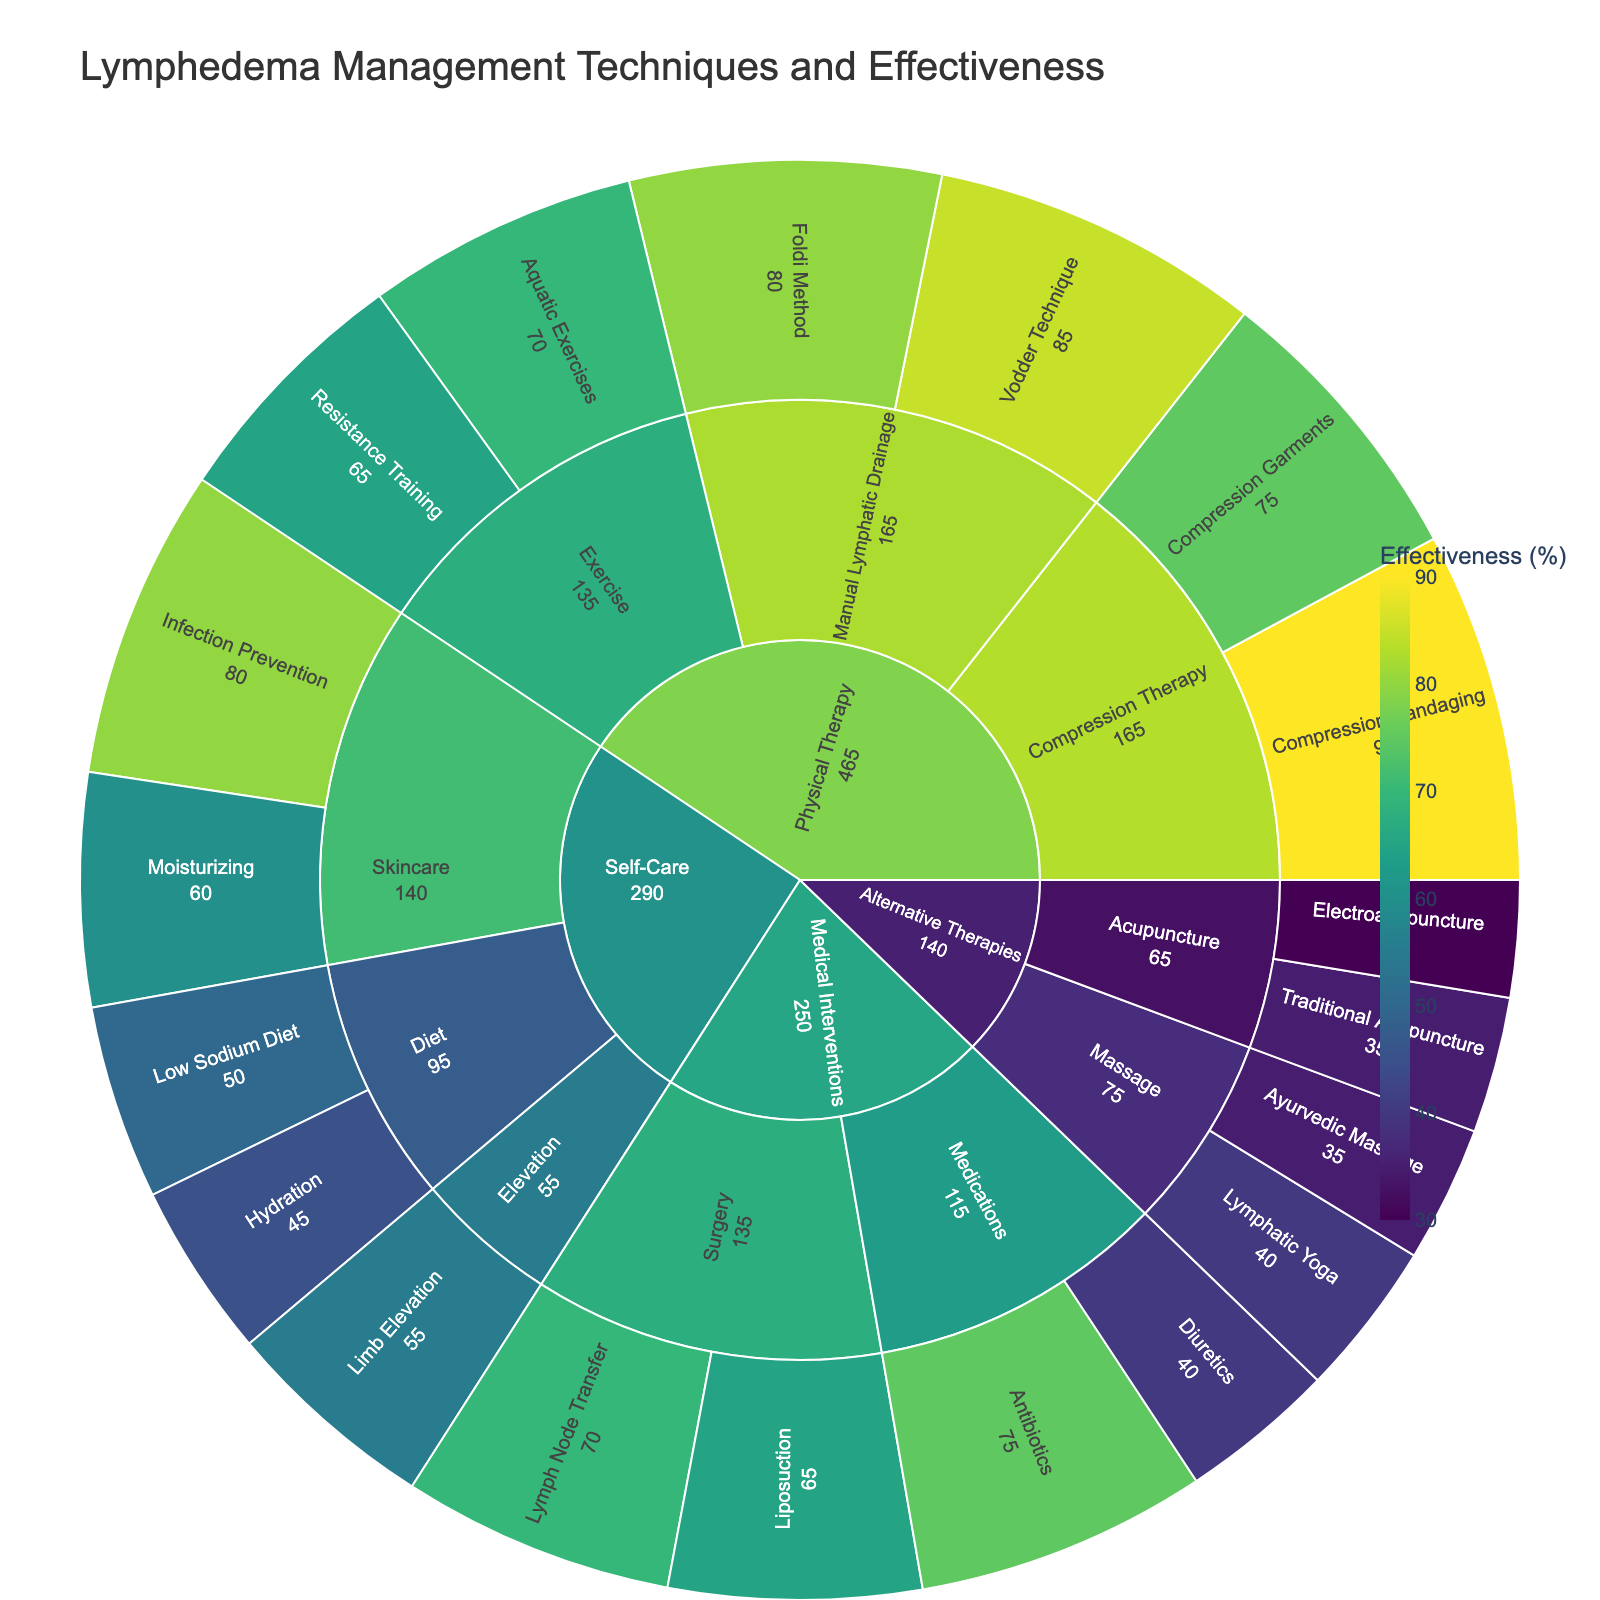What's the most effective lymphedema management technique shown in the figure? From the sunburst plot, identify the slice with the highest effectiveness value. Compression Bandaging under Physical Therapy has the highest value of 90%.
Answer: Compression Bandaging Which category has the highest variety of management techniques? Count the number of segments under each main category in the outermost ring of the sunburst plot. Physical Therapy has the most variety with four subcategories (Manual Lymphatic Drainage, Compression Therapy, Exercise).
Answer: Physical Therapy What is the effectiveness range for Medical Interventions techniques? Look at the slices under Medical Interventions and note the highest and lowest effectiveness values. The highest is Antibiotics at 75%, and the lowest is Diuretics at 40%. The range is calculated as 75% - 40%.
Answer: 35% What is the least effective self-care technique? In the Self-Care category, find the lowest effectiveness value. Hydration under the Diet subcategory has an effectiveness of 45%.
Answer: Hydration How does the effectiveness of Traditional Acupuncture compare to that of Electroacupuncture? Compare the effectiveness values for Traditional Acupuncture (35%) and Electroacupuncture (30%) under Alternative Therapies. Traditional Acupuncture is 5% more effective than Electroacupuncture.
Answer: Traditional Acupuncture What's the combined effectiveness of the Vodder Technique and the Foldi Method? Sum the effectiveness values of both techniques under Manual Lymphatic Drainage. Vodder Technique (85%) + Foldi Method (80%) = 165%.
Answer: 165% In Skincare, which technique is more effective, Moisturizing or Infection Prevention? Compare the effectiveness values of Moisturizing (60%) and Infection Prevention (80%) under Skincare. Infection Prevention is more effective by 20%.
Answer: Infection Prevention Which technique has higher effectiveness: Resistance Training or Lymphatic Yoga? Compare the effectiveness of Resistance Training (65%) under Exercise and Lymphatic Yoga (40%) under Alternative Therapies. Resistance Training is 25% more effective.
Answer: Resistance Training How many techniques in Alternative Therapies have an effectiveness below 40%? Count the techniques in the Alternate Therapies category with effectiveness values below 40%. There are three: Traditional Acupuncture (35%), Electroacupuncture (30%), and Ayurvedic Massage (35%).
Answer: 3 What's the average effectiveness of all techniques in Physical Therapy? Average the effectiveness values of all techniques in Physical Therapy: (85 + 80 + 90 + 75 + 70 + 65) / 6 = 465 / 6 = 77.5%.
Answer: 77.5% 